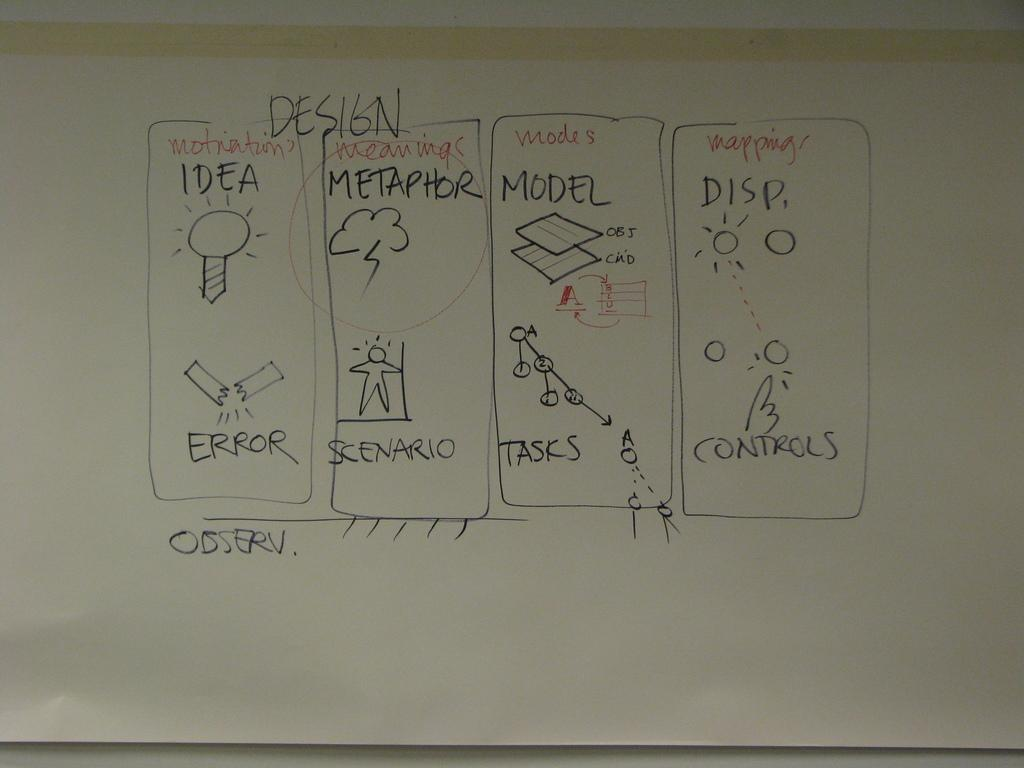Provide a one-sentence caption for the provided image. A whiteboard says Design at the top and has four boxes of information. 